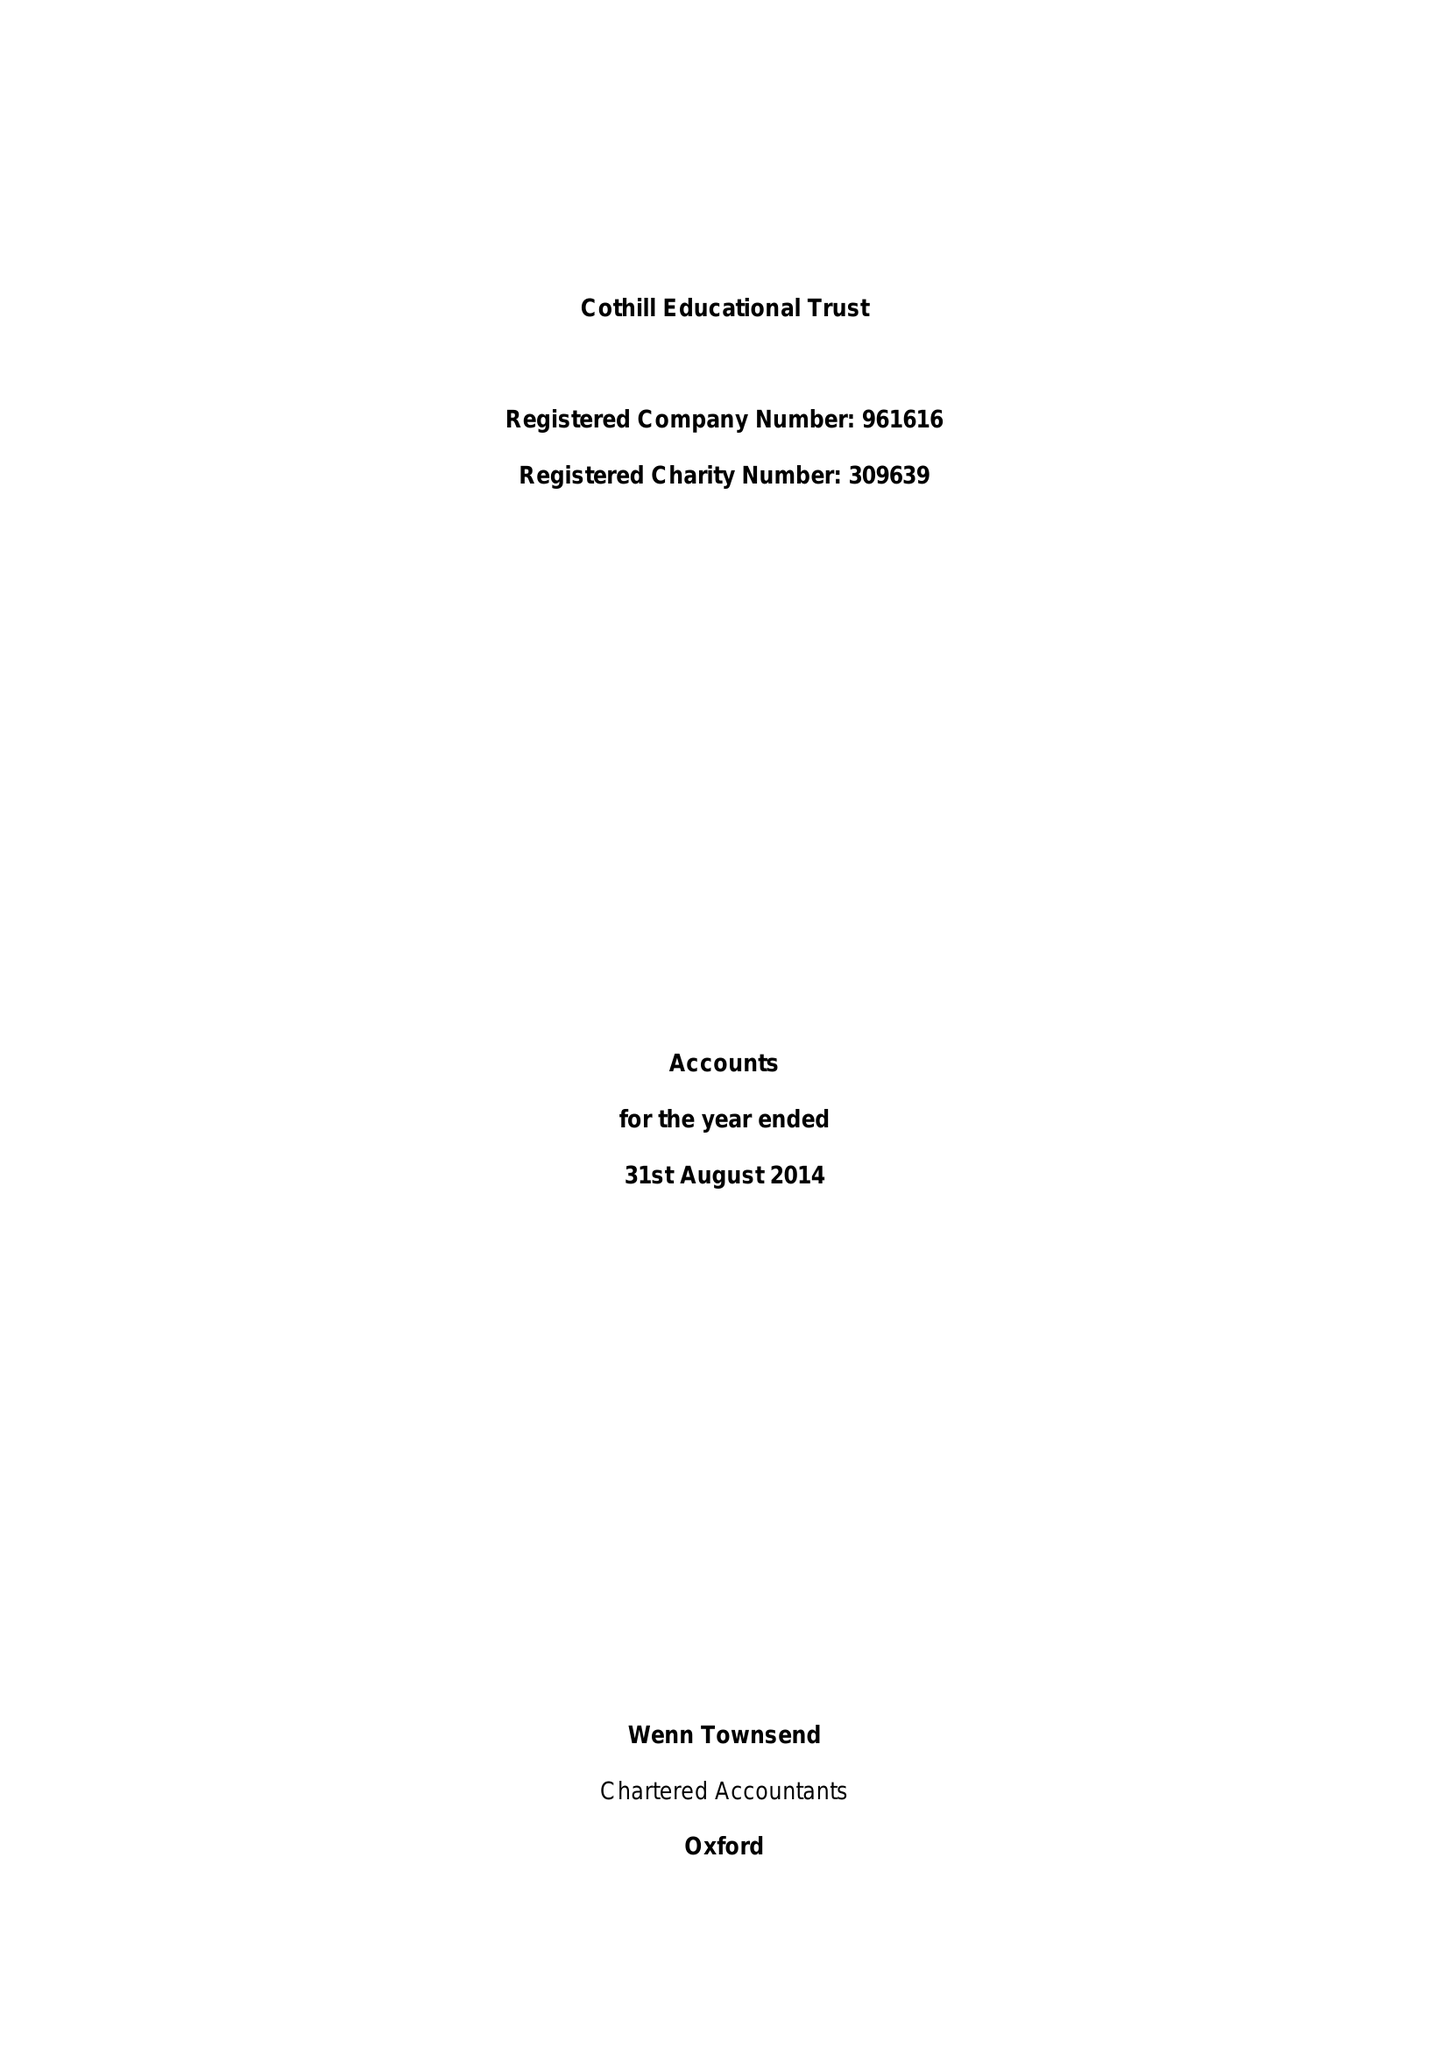What is the value for the address__postcode?
Answer the question using a single word or phrase. OX13 6JN 